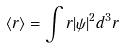Convert formula to latex. <formula><loc_0><loc_0><loc_500><loc_500>\langle r \rangle = \int r | \psi | ^ { 2 } d ^ { 3 } r</formula> 